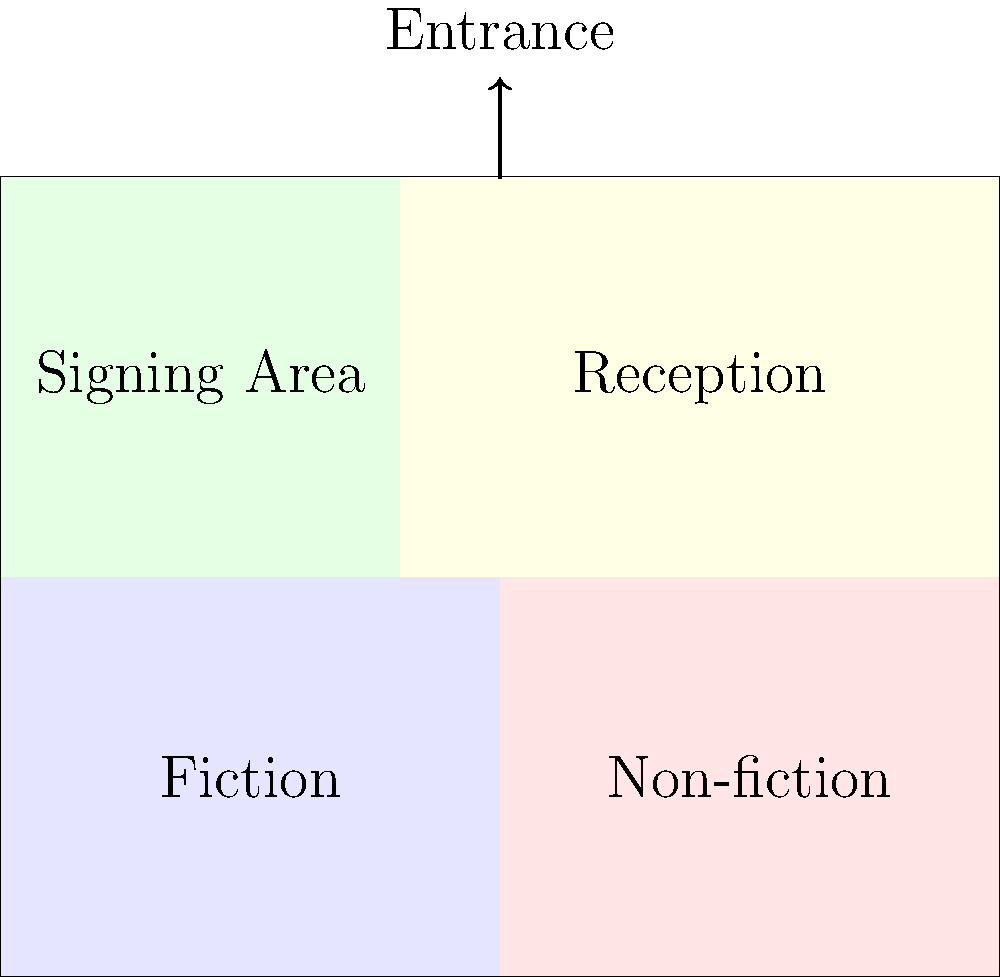As a literary agent, you're tasked with optimizing the layout for your client's publisher booth at a major book fair. Given the 2D floor plan above, which area should be placed closest to the entrance to maximize visitor engagement and potential sales for your novelist client? To determine the optimal layout for maximizing visitor engagement and potential sales for your novelist client, consider the following steps:

1. Analyze the given floor plan:
   - The booth is divided into four sections: Fiction, Non-fiction, Signing Area, and Reception.
   - The entrance is located at the top center of the booth.

2. Consider the visitor flow:
   - Visitors will enter from the top and naturally move into the booth.
   - The area closest to the entrance will receive the most foot traffic and visibility.

3. Evaluate the importance of each section for your novelist client:
   - Fiction: Crucial, as your client is a novelist.
   - Non-fiction: Less relevant for a novelist.
   - Signing Area: Important for author engagement, but not the primary focus for initial attraction.
   - Reception: Necessary but not the main draw for visitors.

4. Prioritize visitor engagement:
   - The Fiction section should be highly visible and easily accessible to attract potential readers.
   - The Signing Area should be nearby but not necessarily the first thing visitors see.

5. Consider sales potential:
   - Placing the Fiction section near the entrance allows for immediate browsing and potential purchases.
   - The Reception area can be slightly further back, as interested visitors will seek it out.

6. Optimize the layout:
   - The current layout already has the Fiction section adjacent to the entrance.
   - This placement is ideal for attracting visitors interested in your novelist client's work.

Given these considerations, the Fiction section, which is already placed closest to the entrance in the current layout, is the optimal choice for maximizing visitor engagement and potential sales for your novelist client.
Answer: Fiction section 